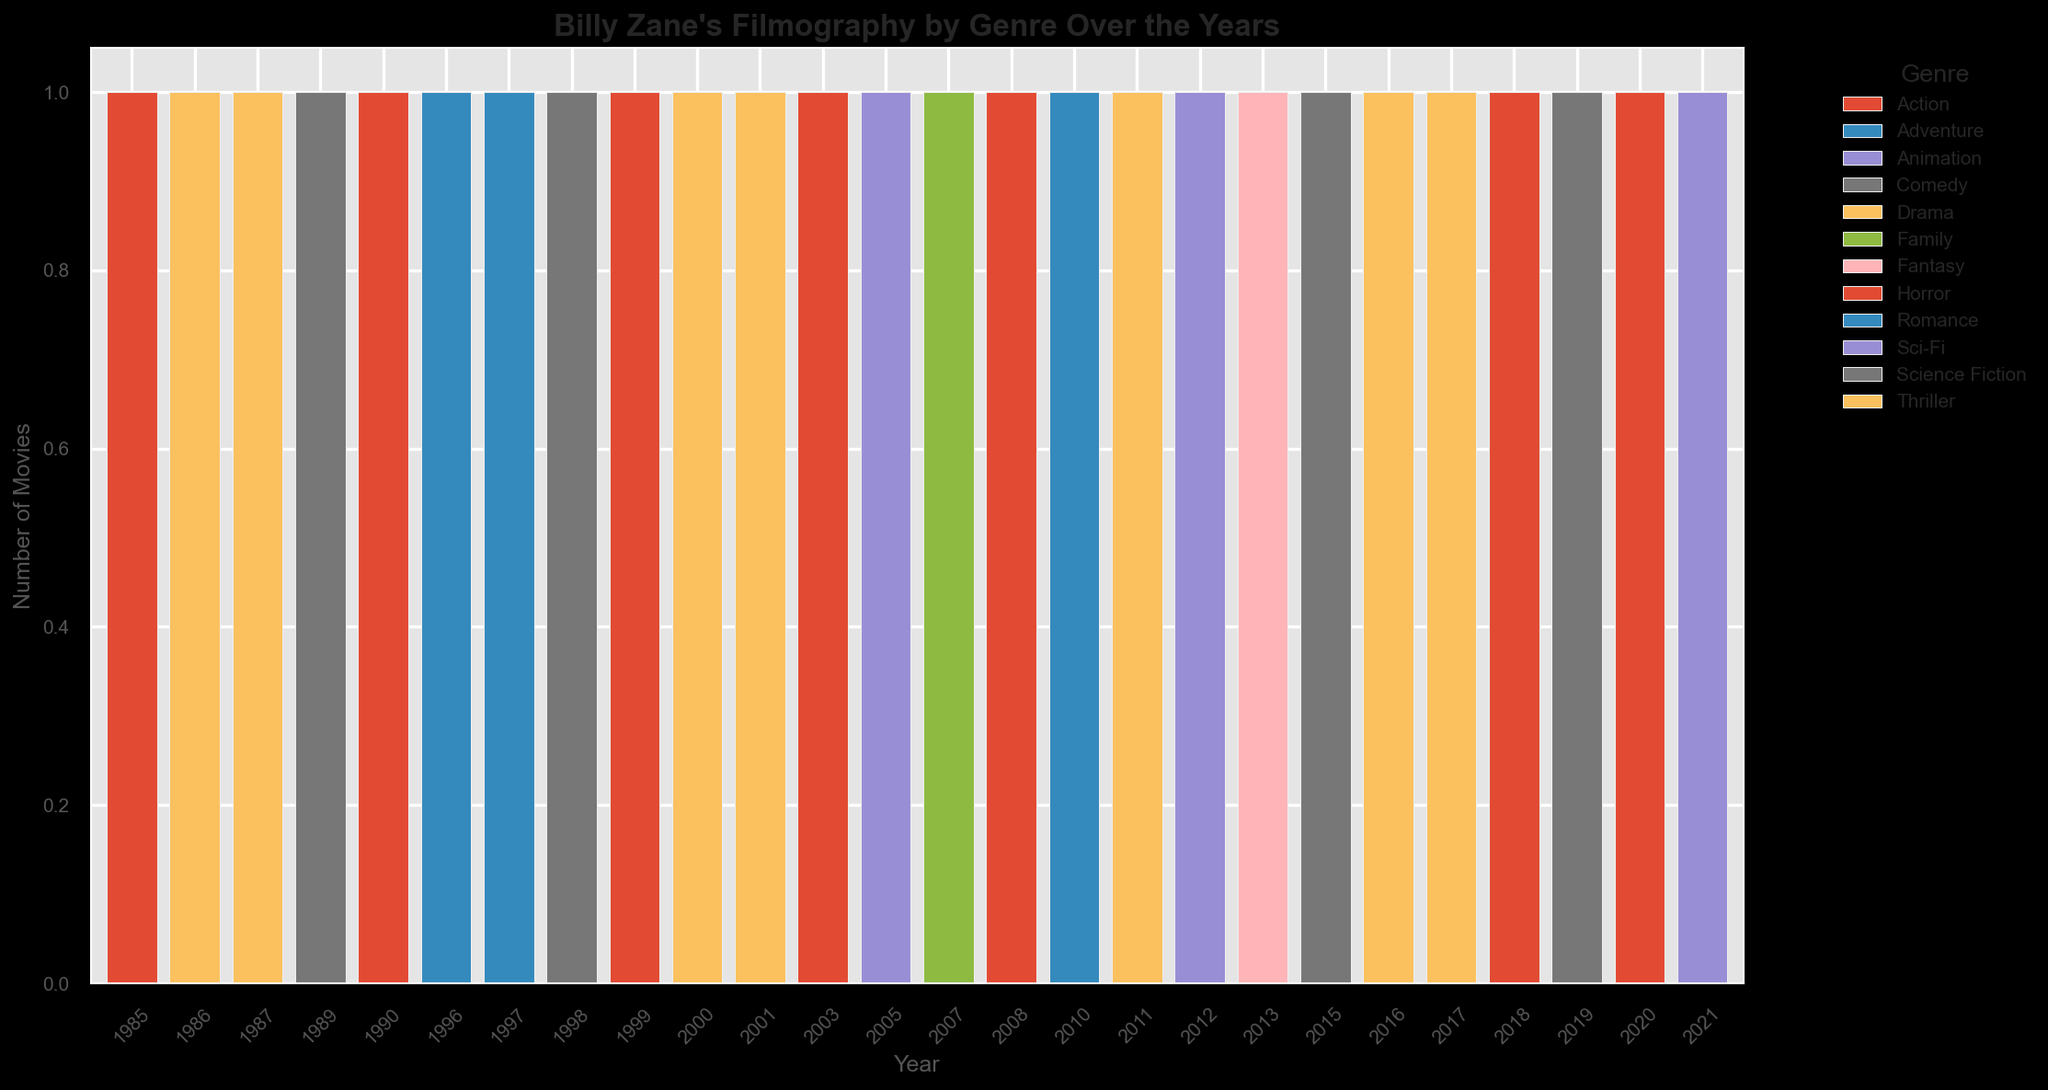What genre appeared most frequently in Billy Zane's filmography over the years? By observing the heights of the different colored bars across the years, we can compare the cumulative heights to see which genre stands out the most.
Answer: Action, Drama Which year featured the most diverse genres in Billy Zane's films? Look at the number of different colored segments (representing genres) in each bar. Count the distinct segments for each year.
Answer: 2011 In which year did Billy Zane star in a Romance movie, and how many other genres did he cover that year? Identify the year with the bar segment colored for Romance (1997), then count the total number of segments in that year's bar.
Answer: 1997, 1 How many Comedy movies did Billy Zane appear in from 1998 to 2015? Identify the bars with Comedy (color) segments between the years 1998 and 2015 and sum their counts.
Answer: 3 Which genre did Billy Zane appear in consistently across the longest range of years, and what is that range? Look for the genre whose color appears in the most consecutive years (vertical segments stacked on top of each other).
Answer: Drama, 1986-2017 How does the number of Action movies compare between the 1980s and 2000s? Count the Action movies in the bars labeled for the years 1980-1989 and then for the years 2000-2009. Compare these counts.
Answer: 1 in 1980s, 2 in 2000s What is the total number of genres Billy Zane covered in the 2010s? Identify the different colored segments in the bars from 2010 to 2019, count the unique segments.
Answer: 7 In which year did Billy Zane star in a Family movie, and which genre was added the next year? Find the year with the Family (color) genre (2007) and check the genres (colors) in the next year's bar (2008).
Answer: 2007, Action What's the total number of movies Billy Zane appeared in across all the years shown? Sum the heights of all the vertical bars, which represent the counts per year.
Answer: 26 How many genres appeared only once across the entire data range? Identify the number of unique colored segments that appear only in one year's bar.
Answer: 3 